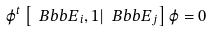<formula> <loc_0><loc_0><loc_500><loc_500>\varphi ^ { t } \left [ { \ B b b E } _ { i } , 1 | { \ B b b E } _ { j } \right ] \varphi = 0</formula> 